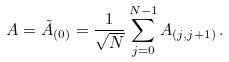Convert formula to latex. <formula><loc_0><loc_0><loc_500><loc_500>A = \tilde { A } _ { ( 0 ) } = \frac { 1 } { \sqrt { N } } \sum _ { j = 0 } ^ { N - 1 } A _ { ( j , j + 1 ) } \, .</formula> 